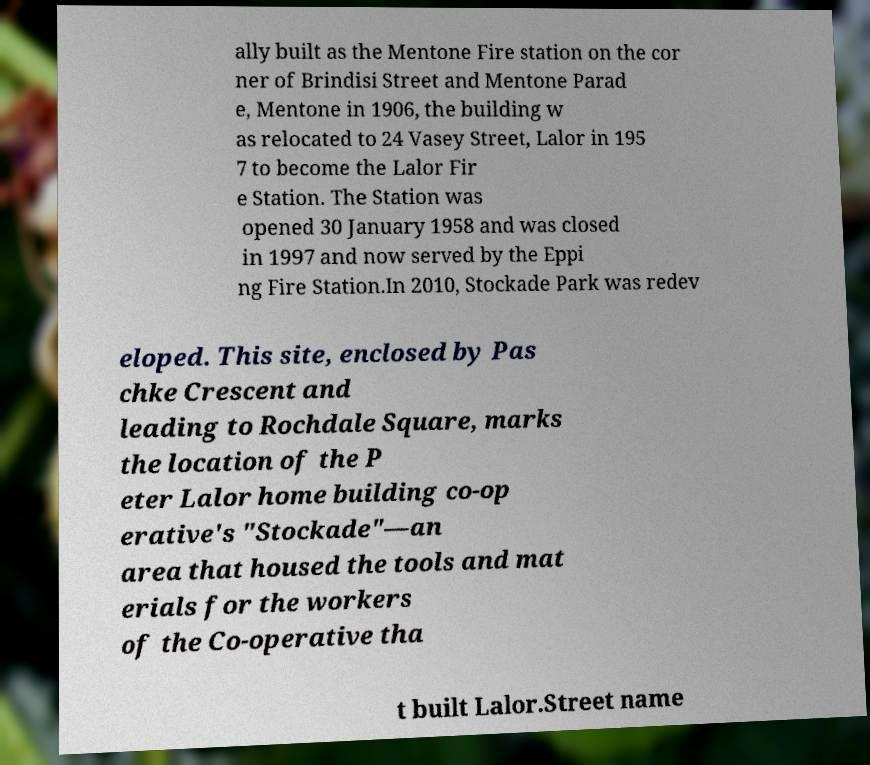Could you extract and type out the text from this image? ally built as the Mentone Fire station on the cor ner of Brindisi Street and Mentone Parad e, Mentone in 1906, the building w as relocated to 24 Vasey Street, Lalor in 195 7 to become the Lalor Fir e Station. The Station was opened 30 January 1958 and was closed in 1997 and now served by the Eppi ng Fire Station.In 2010, Stockade Park was redev eloped. This site, enclosed by Pas chke Crescent and leading to Rochdale Square, marks the location of the P eter Lalor home building co-op erative's "Stockade"—an area that housed the tools and mat erials for the workers of the Co-operative tha t built Lalor.Street name 